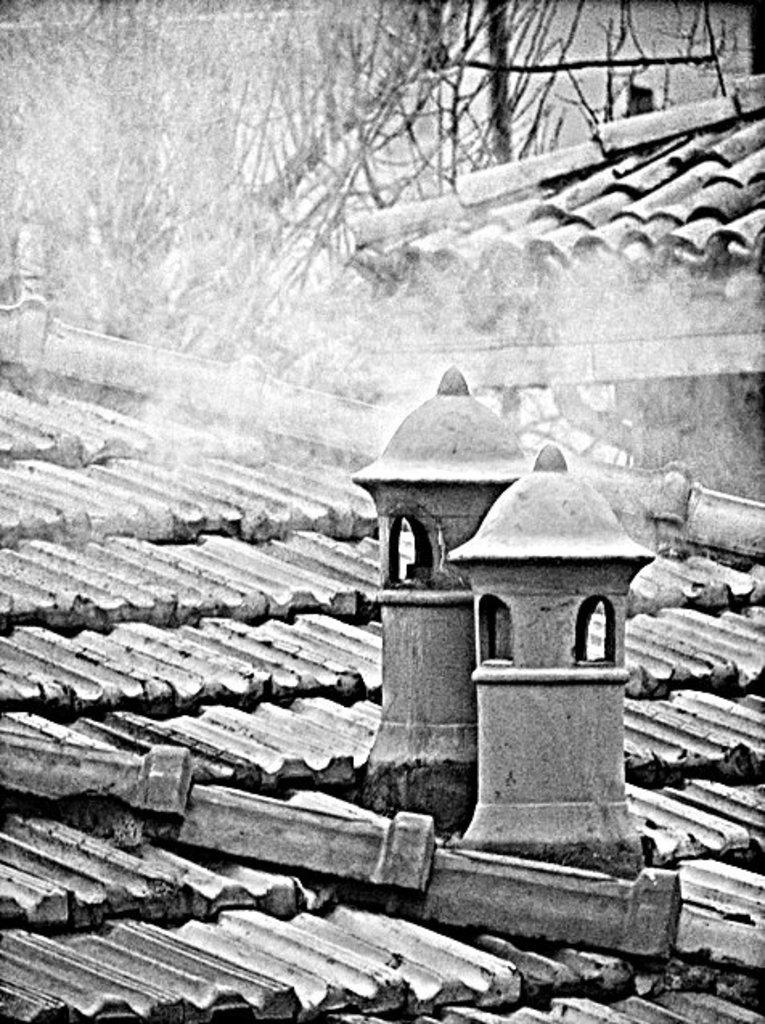What is the color scheme of the image? The image is black and white. What structures can be seen in the image? There are roofs in the image. What type of natural elements are visible in the background of the image? There are trees in the background of the image. Can you tell me how many rabbits are hopping around in the image? There are no rabbits present in the image; it features black and white roofs and trees in the background. What decision is being made by the mother in the image? There is no mother or decision-making process depicted in the image. 